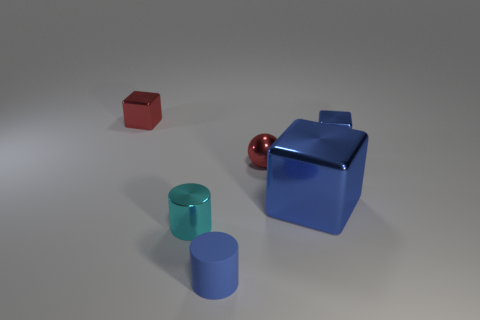Is there anything else that has the same material as the blue cylinder?
Your response must be concise. No. Does the cyan cylinder have the same size as the blue matte object to the right of the tiny red block?
Give a very brief answer. Yes. How many cylinders are the same color as the large metallic block?
Offer a very short reply. 1. What number of objects are small things or metal things that are behind the small sphere?
Offer a very short reply. 5. There is a cylinder on the right side of the tiny cyan cylinder; does it have the same size as the red thing that is right of the small red block?
Your answer should be very brief. Yes. Are there any big blue cubes that have the same material as the tiny sphere?
Make the answer very short. Yes. The big object is what shape?
Keep it short and to the point. Cube. What is the shape of the red thing right of the tiny blue matte cylinder in front of the big cube?
Your answer should be compact. Sphere. How many other things are the same shape as the large blue metallic object?
Your response must be concise. 2. There is a blue metallic object in front of the red object to the right of the blue matte cylinder; how big is it?
Offer a terse response. Large. 